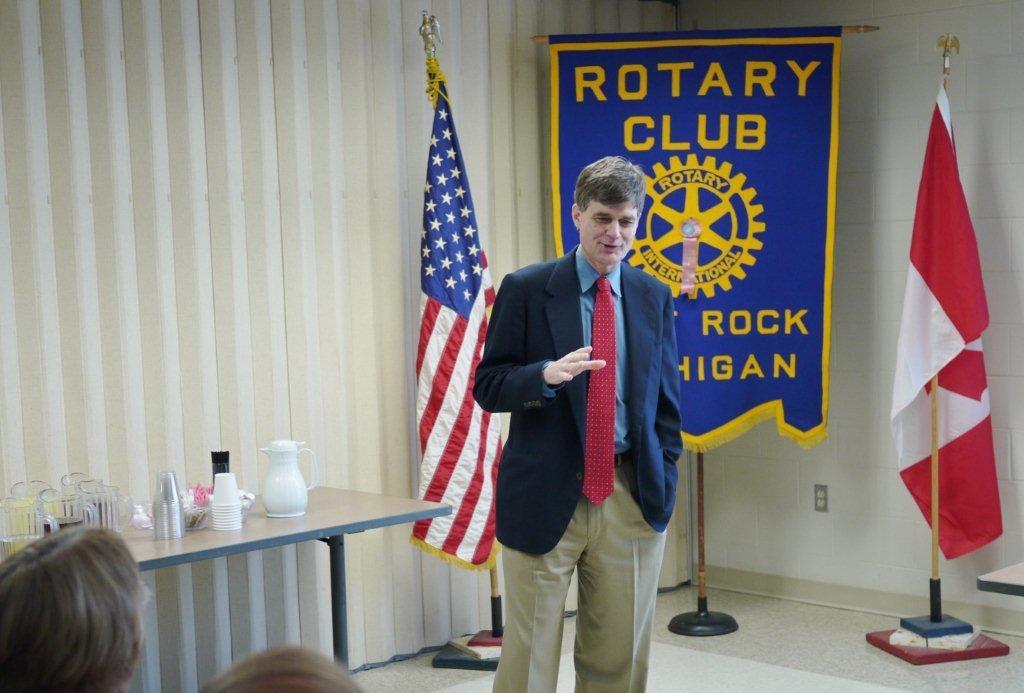Please provide a concise description of this image. In this image we can see a person wearing suit standing on left side of the image there is a table on which there are some jugs, glasses, cups and in the background of the image there are flags. 